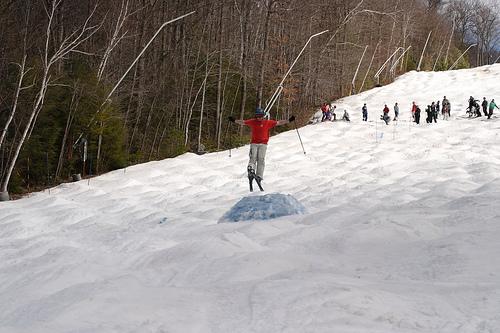Is the skier airborne?
Answer briefly. Yes. Is there any snow on the trees in this picture?
Keep it brief. No. How steep is the slope?
Concise answer only. Very. 